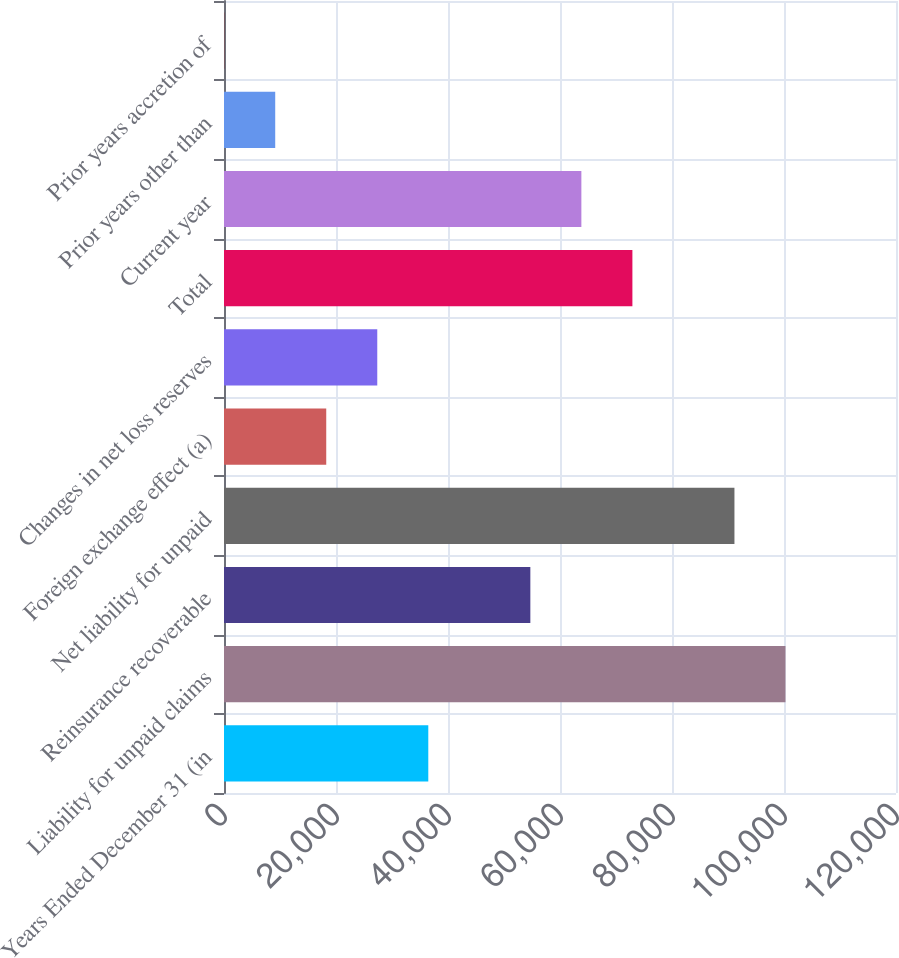<chart> <loc_0><loc_0><loc_500><loc_500><bar_chart><fcel>Years Ended December 31 (in<fcel>Liability for unpaid claims<fcel>Reinsurance recoverable<fcel>Net liability for unpaid<fcel>Foreign exchange effect (a)<fcel>Changes in net loss reserves<fcel>Total<fcel>Current year<fcel>Prior years other than<fcel>Prior years accretion of<nl><fcel>36480.8<fcel>100263<fcel>54704.2<fcel>91151<fcel>18257.4<fcel>27369.1<fcel>72927.6<fcel>63815.9<fcel>9145.7<fcel>34<nl></chart> 